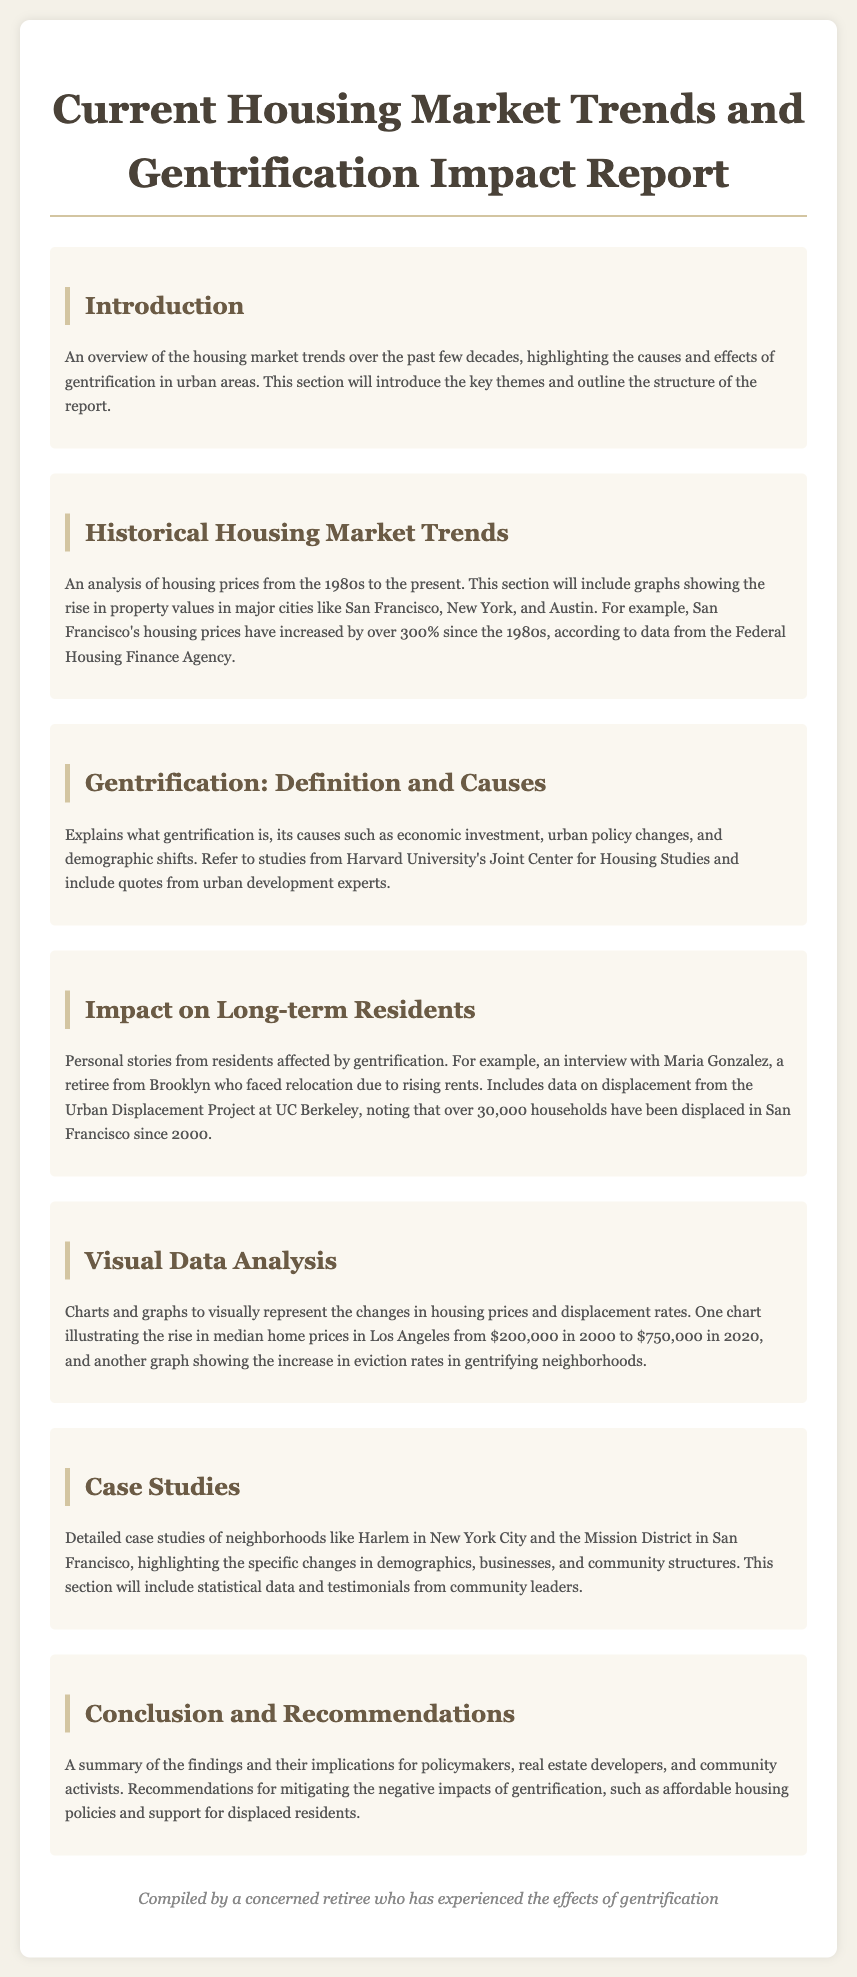What is the main focus of the report? The report focuses on analyzing current housing market trends and the impact of gentrification, including personal stories and visual data.
Answer: housing market trends and gentrification How much have San Francisco's housing prices increased since the 1980s? The report states that San Francisco's housing prices have increased by over 300% since the 1980s.
Answer: over 300% What is defined in the section "Gentrification: Definition and Causes"? This section explains what gentrification is and discusses its causes.
Answer: gentrification and its causes Who is mentioned in the interviews related to gentrification impacts? Maria Gonzalez, a retiree from Brooklyn, is mentioned in the interviews regarding her experiences with rising rents.
Answer: Maria Gonzalez What significant data point does the Urban Displacement Project provide? The Urban Displacement Project notes that over 30,000 households have been displaced in San Francisco since 2000.
Answer: over 30,000 households In what year did the median home price in Los Angeles rise to $750,000? The report mentions that the median home price in Los Angeles rose to $750,000 in 2020.
Answer: 2020 What are recommendations mentioned for mitigating gentrification's effects? The report suggests affordable housing policies and support for displaced residents as recommendations.
Answer: affordable housing policies and support for displaced residents Which neighborhoods are used as case studies in the report? The report includes case studies of neighborhoods like Harlem in New York City and the Mission District in San Francisco.
Answer: Harlem and Mission District What does the introduction summarize? The introduction summarizes housing market trends over the past few decades and outlines the report's structure.
Answer: housing market trends and report structure 